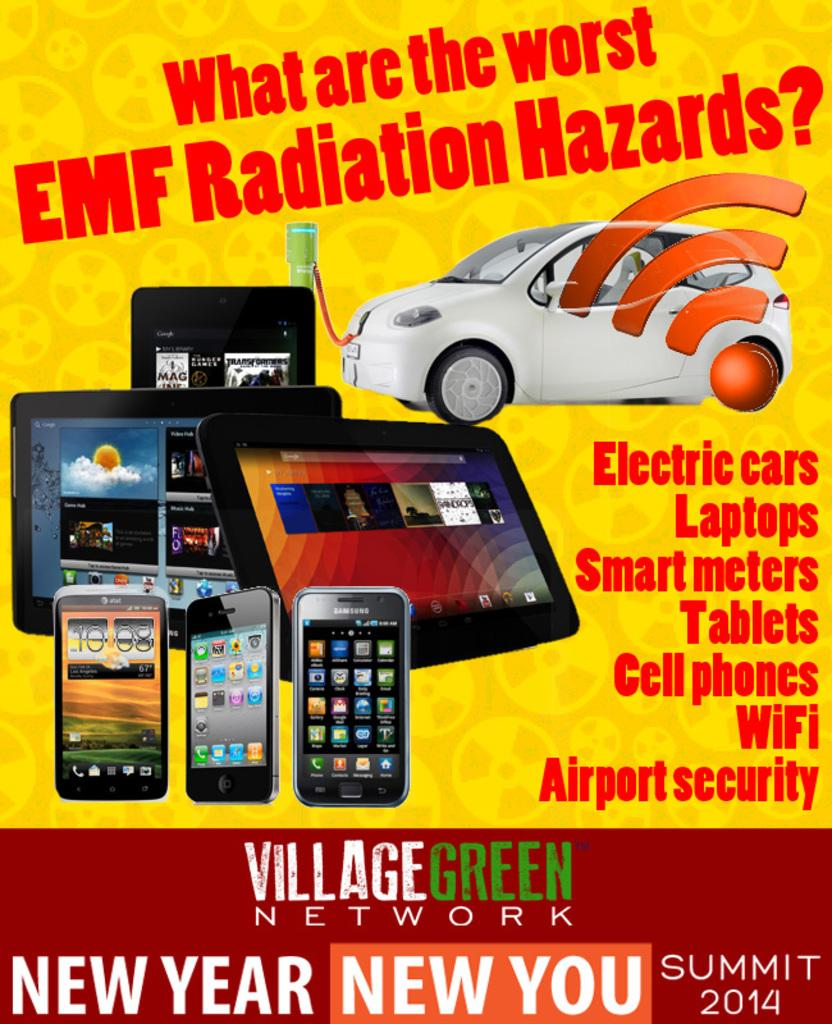What is the main subject of the poster in the image? The poster features mobile phones, tablets, and a white color car. What colors are used in the poster? The poster is in yellow and red colors. Are there any text or labels on the poster? Yes, there is edited text on the poster. What type of insurance is advertised on the poster? There is no mention of insurance on the poster; it features mobile phones, tablets, and a car. Can you tell me how many rays are depicted on the poster? There are no rays depicted on the poster; it features mobile phones, tablets, and a car with edited text. 